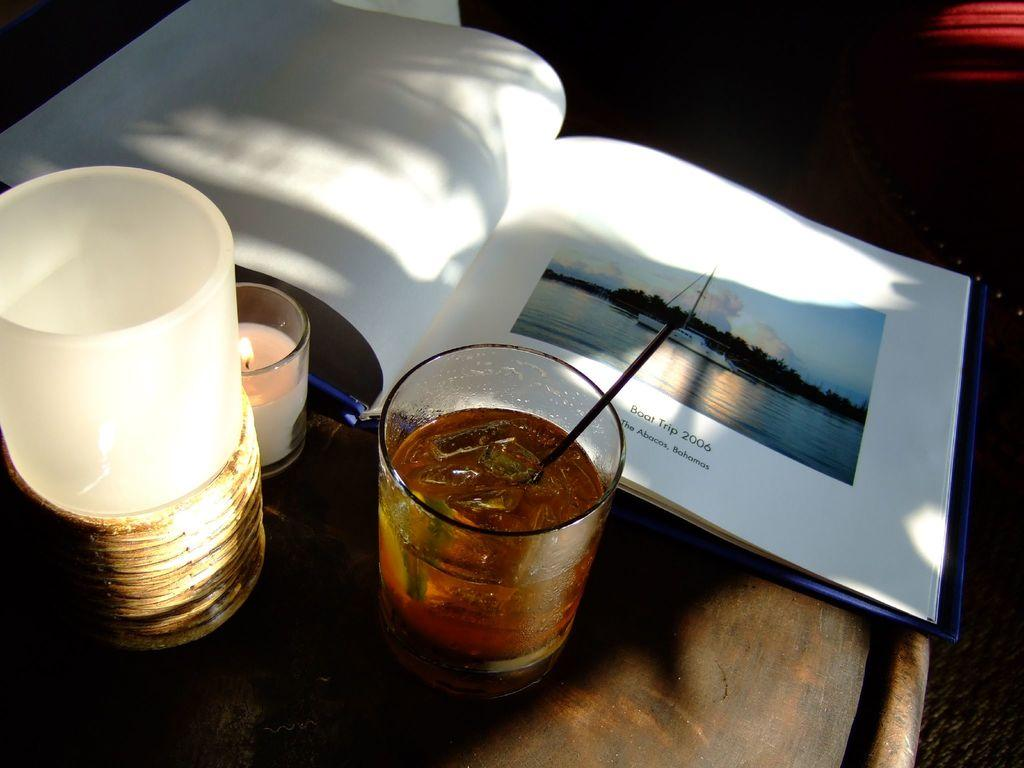<image>
Render a clear and concise summary of the photo. A glass is in front of a book that is turned to a page that says Boat Trip 2006. 